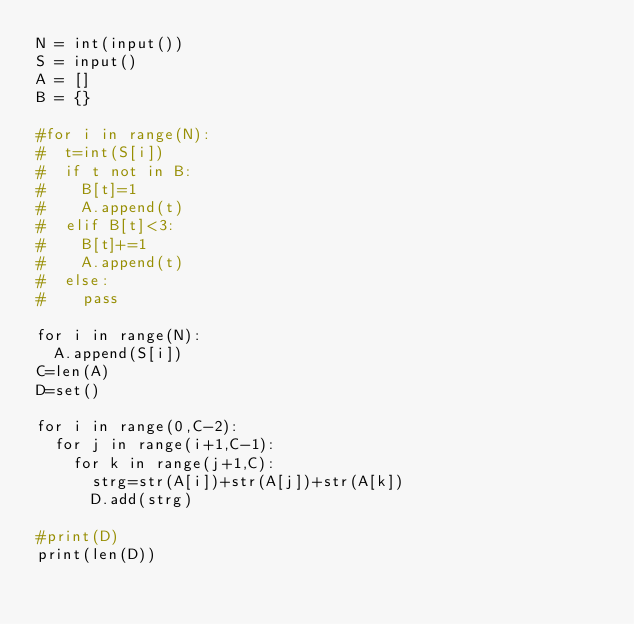<code> <loc_0><loc_0><loc_500><loc_500><_Python_>N = int(input())
S = input()
A = []
B = {}

#for i in range(N):
#  t=int(S[i])
#  if t not in B:
#    B[t]=1
#    A.append(t)
#  elif B[t]<3:
#    B[t]+=1
#    A.append(t)
#  else:
#    pass

for i in range(N):
  A.append(S[i])
C=len(A)
D=set()

for i in range(0,C-2):
  for j in range(i+1,C-1):
    for k in range(j+1,C):
      strg=str(A[i])+str(A[j])+str(A[k])
      D.add(strg)
                 
#print(D)
print(len(D))</code> 